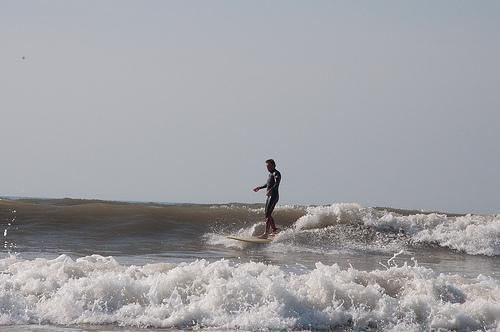How many wakeboard?
Give a very brief answer. 1. 